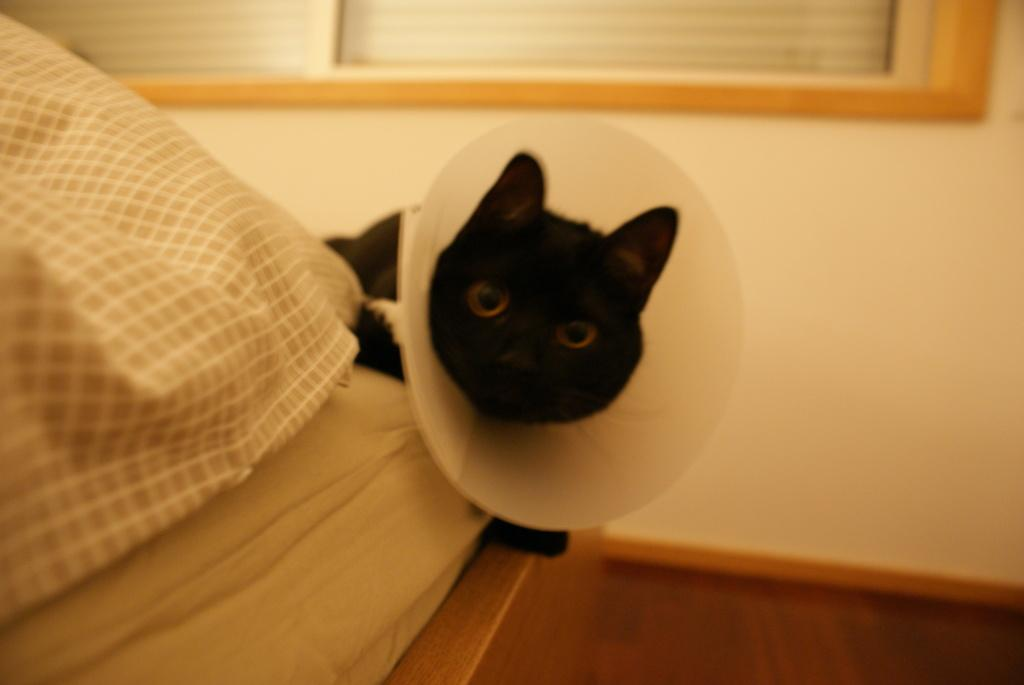What animal is in the middle of the image? There is a cat in the middle of the image. What is behind the cat? There is a wall behind the cat. Where is the bed located in the image? The bed is in the bottom left side of the image. What type of advertisement can be seen on the cat's collar in the image? There is no advertisement or collar present on the cat in the image. 